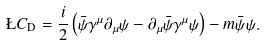Convert formula to latex. <formula><loc_0><loc_0><loc_500><loc_500>\L C _ { \text {D} } = \frac { i } { 2 } \left ( \bar { \psi } \gamma ^ { \mu } \partial _ { \mu } \psi - \partial _ { \mu } \bar { \psi } \gamma ^ { \mu } \psi \right ) - m \bar { \psi } \psi .</formula> 